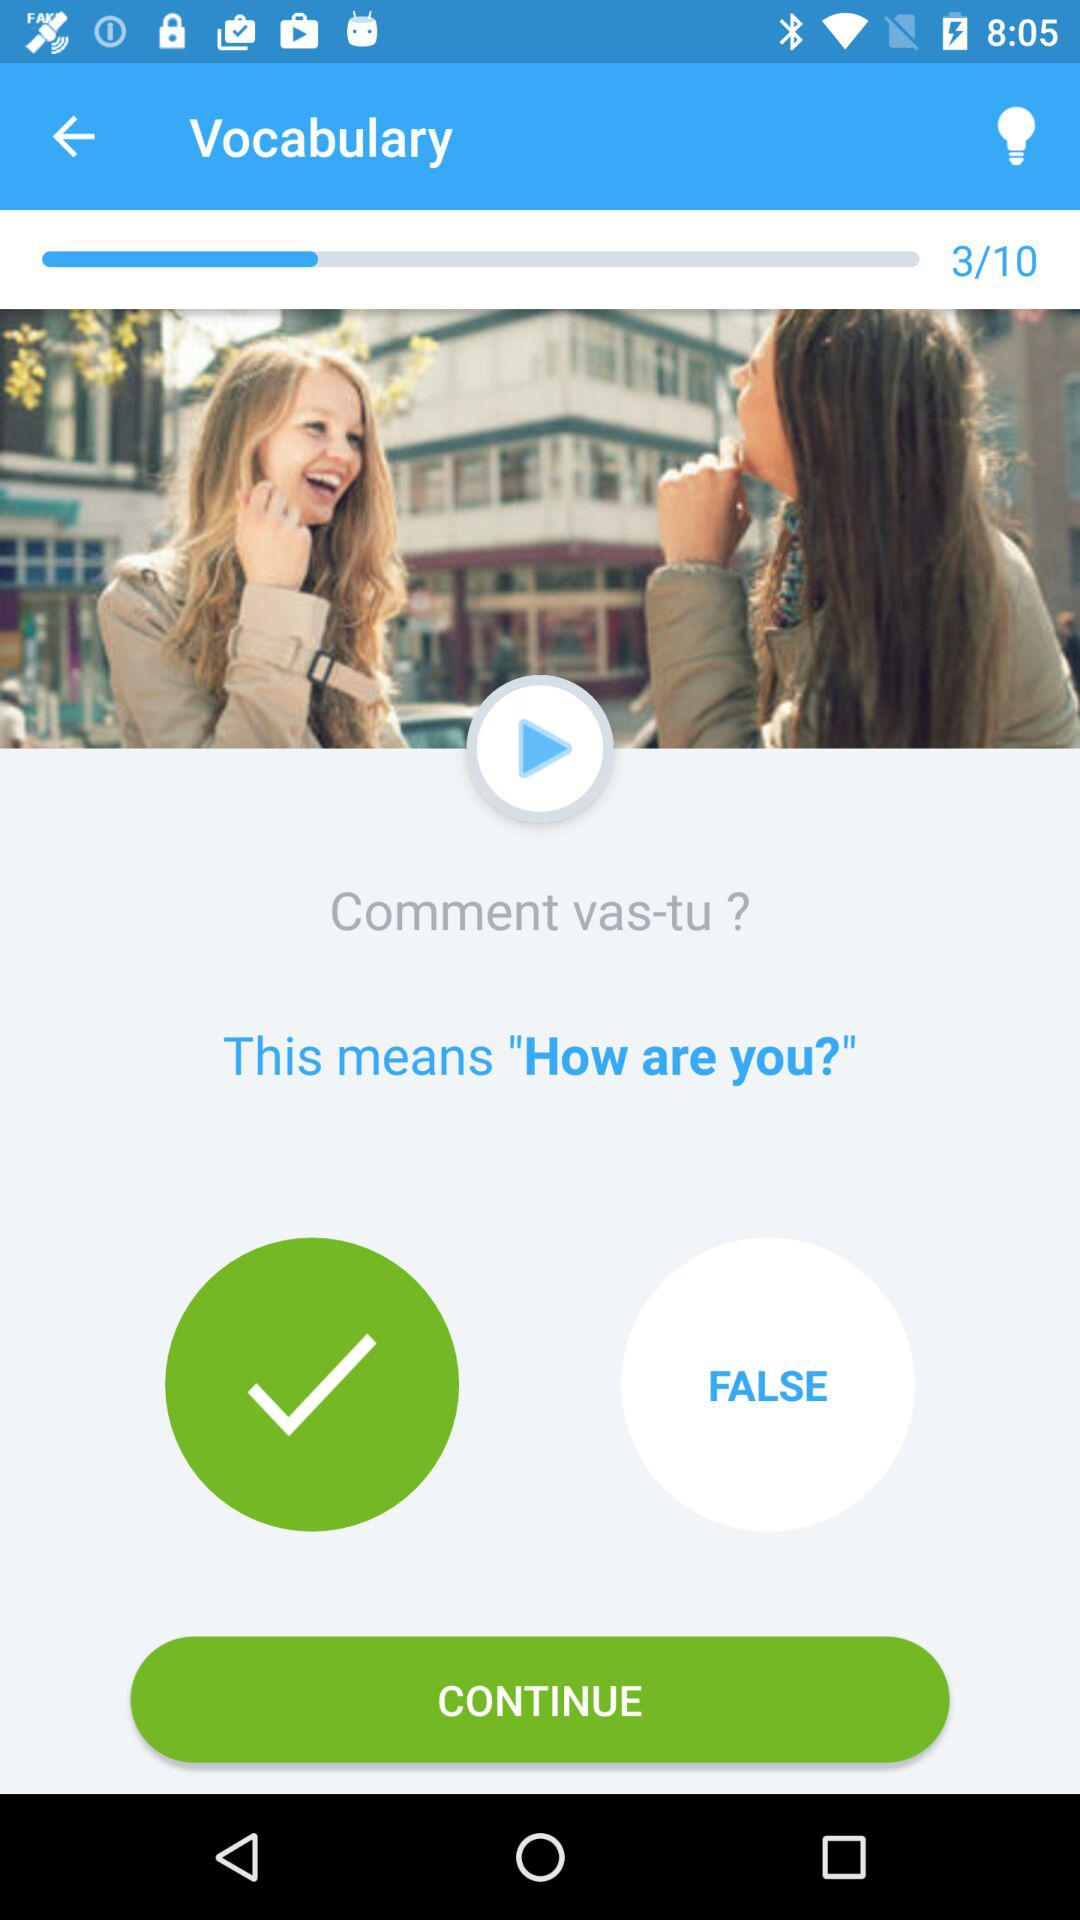Which question am I on in "Vocabulary"? You are on the third question in "Vocabulary". 